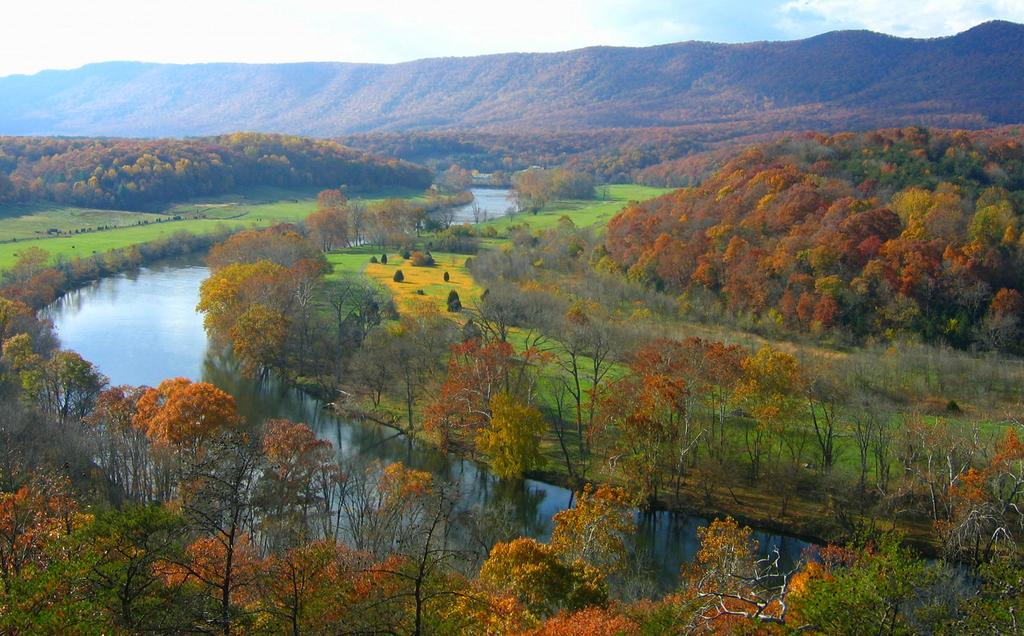What type of view is provided in the image? The image shows an aerial view of the scenery. What type of surface can be seen in the image? There are grass surfaces in the image. What type of vegetation is present in the image? Plants and trees are visible in the image. What natural features can be seen in the image? Water ways, trees, hills, and the sky are visible in the image. How many girls are holding yaks in the image? There are no girls or yaks present in the image. What is the color of the finger that is pointing at the sky in the image? There is no finger pointing at the sky in the image. 